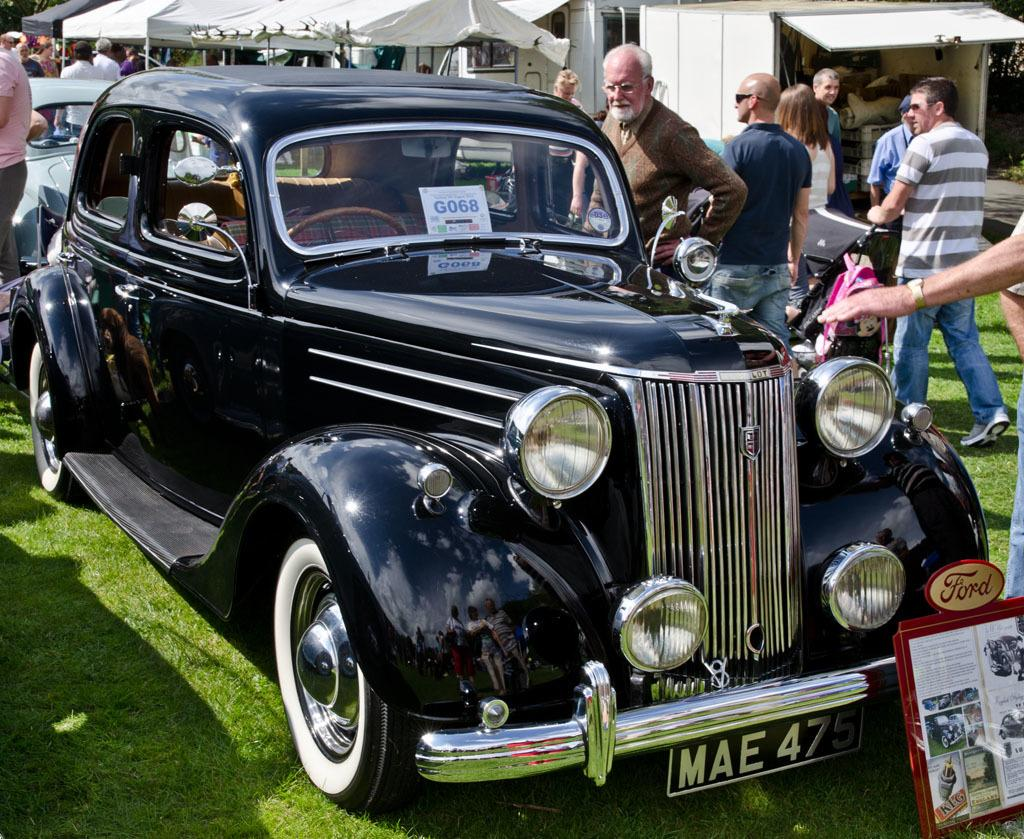What type of vehicles can be seen in the image? There are cars in the image. What are the people in the image doing? The people in the image are standing. What type of temporary shelter is present in the image? There are tents in the image. What type of vegetation is visible in the image? There is grass in the image. What is the tax rate for the cars in the image? There is no information about tax rates in the image, as it only shows cars, people, tents, and grass. How many steps are required to reach the tents from the cars in the image? The image does not provide enough information to determine the distance or number of steps between the cars and tents. 